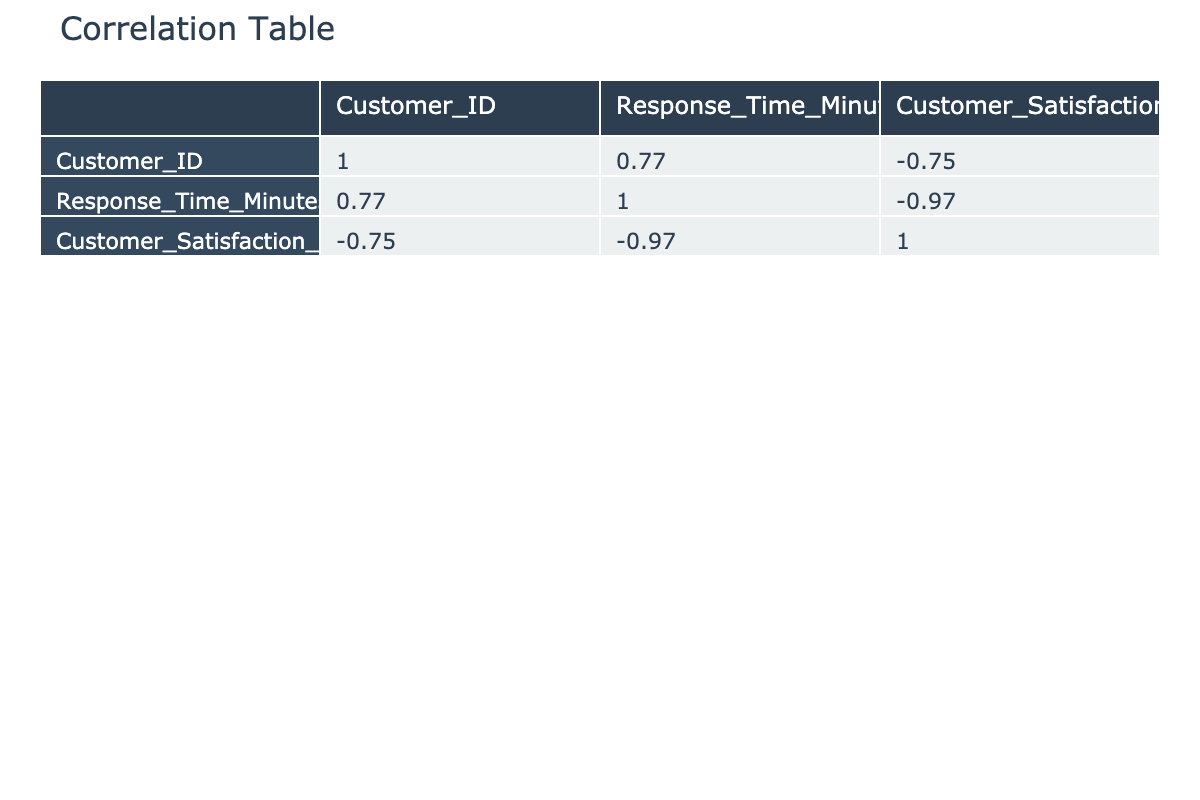What is the correlation coefficient between Response Time and Customer Satisfaction Score? The correlation coefficient for Response Time and Customer Satisfaction Score is -0.95, indicating a strong negative correlation. This means that as response time increases, customer satisfaction scores tend to decrease.
Answer: -0.95 What is the Customer Satisfaction Score for the fastest response time? The fastest response time is 5 minutes, which corresponds to a Customer Satisfaction Score of 92.
Answer: 92 Is the correlation between Response Time and Customer Satisfaction Score positive or negative? The correlation between Response Time and Customer Satisfaction Score is negative, as indicated by a correlation coefficient of -0.95. This means that higher response times are associated with lower customer satisfaction scores.
Answer: Negative What is the average Customer Satisfaction Score for response times of 30 minutes or less? The Customer Satisfaction Scores for response times of 5, 10, 15, 20, 25, and 30 minutes are 92, 85, 78, 70, 64, and 58 respectively. Summing these scores gives 92 + 85 + 78 + 70 + 64 + 58 = 447. There are 6 data points, so the average is 447/6 = 74.5.
Answer: 74.5 Which response time correlates with the lowest Customer Satisfaction Score? The lowest Customer Satisfaction Score is 35, which correlates with a response time of 70 minutes. This indicates that longer response times are linked to lower satisfaction among customers.
Answer: 70 minutes Does any Customer Satisfaction Score exceed 90? Yes, there is at least one Customer Satisfaction Score that exceeds 90. Specifically, the score for a 5-minute response time is 92, which is above 90.
Answer: Yes What is the median Response Time for all customers? The Response Times in ascending order are: 5, 10, 15, 15, 20, 25, 25, 30, 35, 35, 40, 45, 50, 55, 60, 60, 65, 70. With 20 data points, the median is the average of the 10th and 11th values, which are 35 and 40. Therefore, (35 + 40) / 2 = 37.5.
Answer: 37.5 How many customers have a Customer Satisfaction Score below 50? The Customer Satisfaction Scores below 50 are found at Response Times of 40, 45, 50, 55, 60, and 65 minutes, which correspond to scores of 50, 48, 45, 42, 40, 39, 37, and 35. There are 6 customers with scores below 50.
Answer: 6 